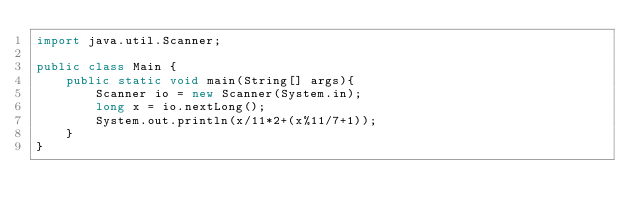Convert code to text. <code><loc_0><loc_0><loc_500><loc_500><_Java_>import java.util.Scanner;

public class Main {
	public static void main(String[] args){
		Scanner io = new Scanner(System.in);
		long x = io.nextLong();
		System.out.println(x/11*2+(x%11/7+1));
	}
}</code> 